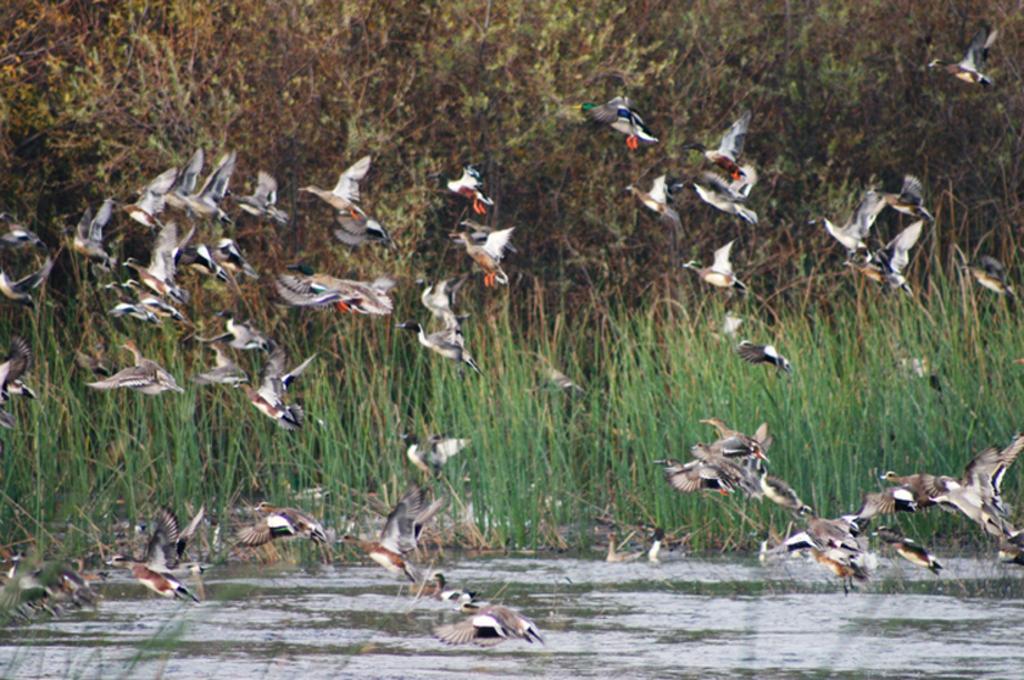Could you give a brief overview of what you see in this image? In this image I can see water, grass, number of trees and number of birds. 